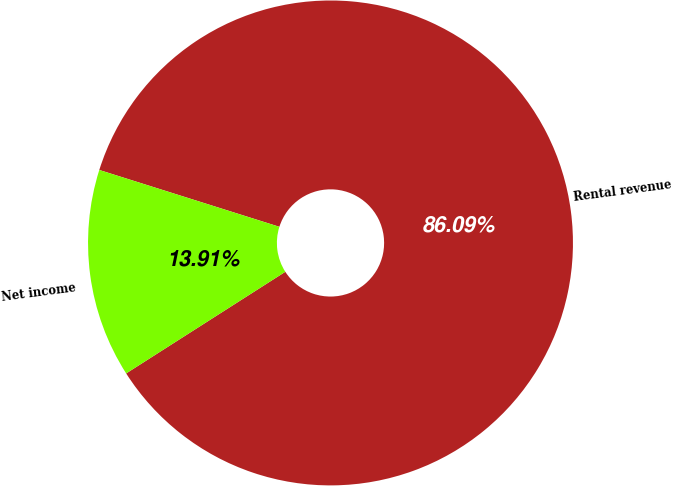Convert chart. <chart><loc_0><loc_0><loc_500><loc_500><pie_chart><fcel>Rental revenue<fcel>Net income<nl><fcel>86.09%<fcel>13.91%<nl></chart> 